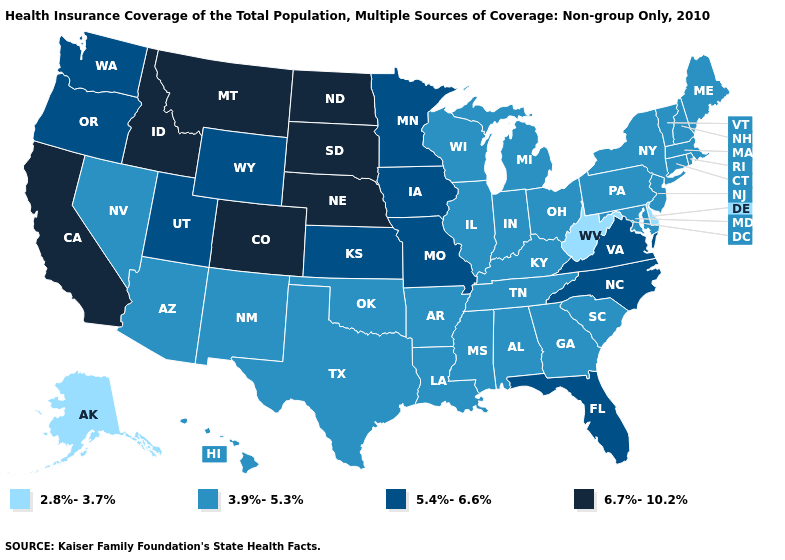Does Nebraska have a higher value than Arizona?
Give a very brief answer. Yes. What is the value of Wyoming?
Be succinct. 5.4%-6.6%. Which states have the lowest value in the USA?
Be succinct. Alaska, Delaware, West Virginia. Among the states that border South Carolina , does North Carolina have the highest value?
Quick response, please. Yes. Does New Jersey have a higher value than Alaska?
Be succinct. Yes. What is the value of Maryland?
Quick response, please. 3.9%-5.3%. Which states have the highest value in the USA?
Concise answer only. California, Colorado, Idaho, Montana, Nebraska, North Dakota, South Dakota. Does Alaska have the lowest value in the USA?
Short answer required. Yes. Which states have the highest value in the USA?
Keep it brief. California, Colorado, Idaho, Montana, Nebraska, North Dakota, South Dakota. Among the states that border Idaho , does Nevada have the lowest value?
Be succinct. Yes. Which states have the lowest value in the South?
Concise answer only. Delaware, West Virginia. What is the value of Oklahoma?
Give a very brief answer. 3.9%-5.3%. Among the states that border North Carolina , does Virginia have the highest value?
Give a very brief answer. Yes. 